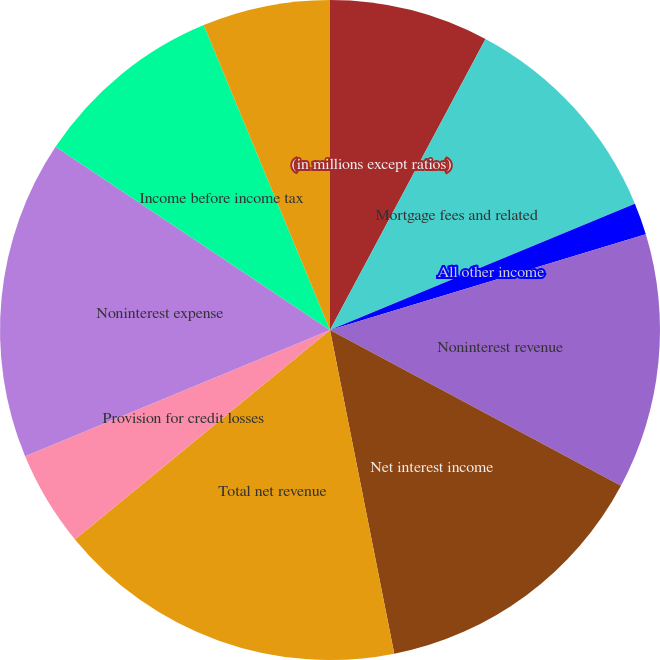<chart> <loc_0><loc_0><loc_500><loc_500><pie_chart><fcel>(in millions except ratios)<fcel>Mortgage fees and related<fcel>All other income<fcel>Noninterest revenue<fcel>Net interest income<fcel>Total net revenue<fcel>Provision for credit losses<fcel>Noninterest expense<fcel>Income before income tax<fcel>Net income<nl><fcel>7.81%<fcel>10.94%<fcel>1.57%<fcel>12.5%<fcel>14.06%<fcel>17.18%<fcel>4.69%<fcel>15.62%<fcel>9.38%<fcel>6.25%<nl></chart> 